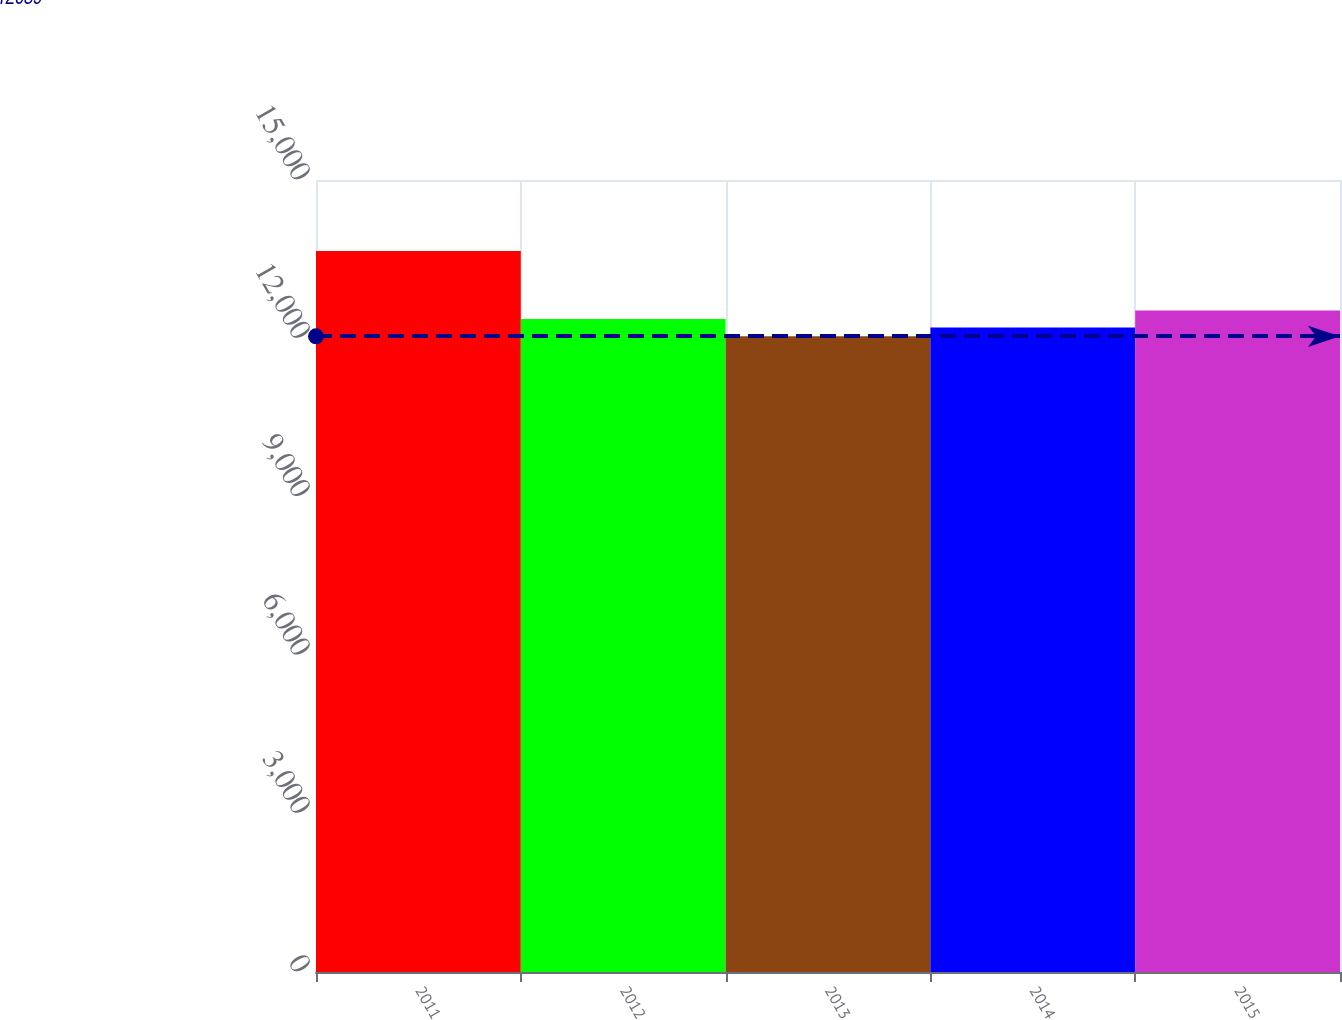<chart> <loc_0><loc_0><loc_500><loc_500><bar_chart><fcel>2011<fcel>2012<fcel>2013<fcel>2014<fcel>2015<nl><fcel>13653<fcel>12368.4<fcel>12039<fcel>12207<fcel>12529.8<nl></chart> 